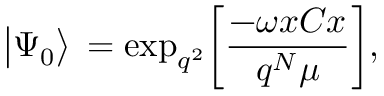Convert formula to latex. <formula><loc_0><loc_0><loc_500><loc_500>\Big | \Psi _ { 0 } \Big > \, = e x p _ { q ^ { 2 } } \Big [ { \frac { - \omega x C x } { q ^ { N } \mu } } \Big ] ,</formula> 